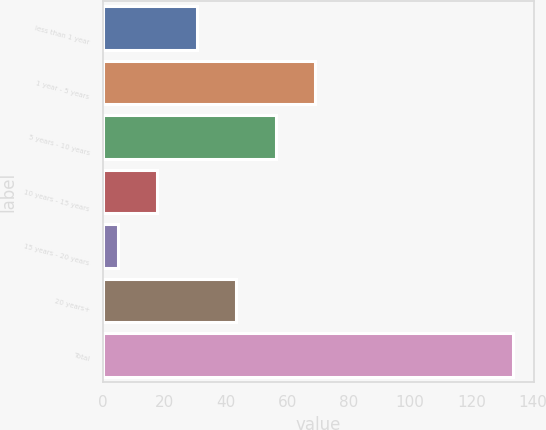Convert chart to OTSL. <chart><loc_0><loc_0><loc_500><loc_500><bar_chart><fcel>less than 1 year<fcel>1 year - 5 years<fcel>5 years - 10 years<fcel>10 years - 15 years<fcel>15 years - 20 years<fcel>20 years+<fcel>Total<nl><fcel>30.48<fcel>69.15<fcel>56.26<fcel>17.59<fcel>4.7<fcel>43.37<fcel>133.6<nl></chart> 